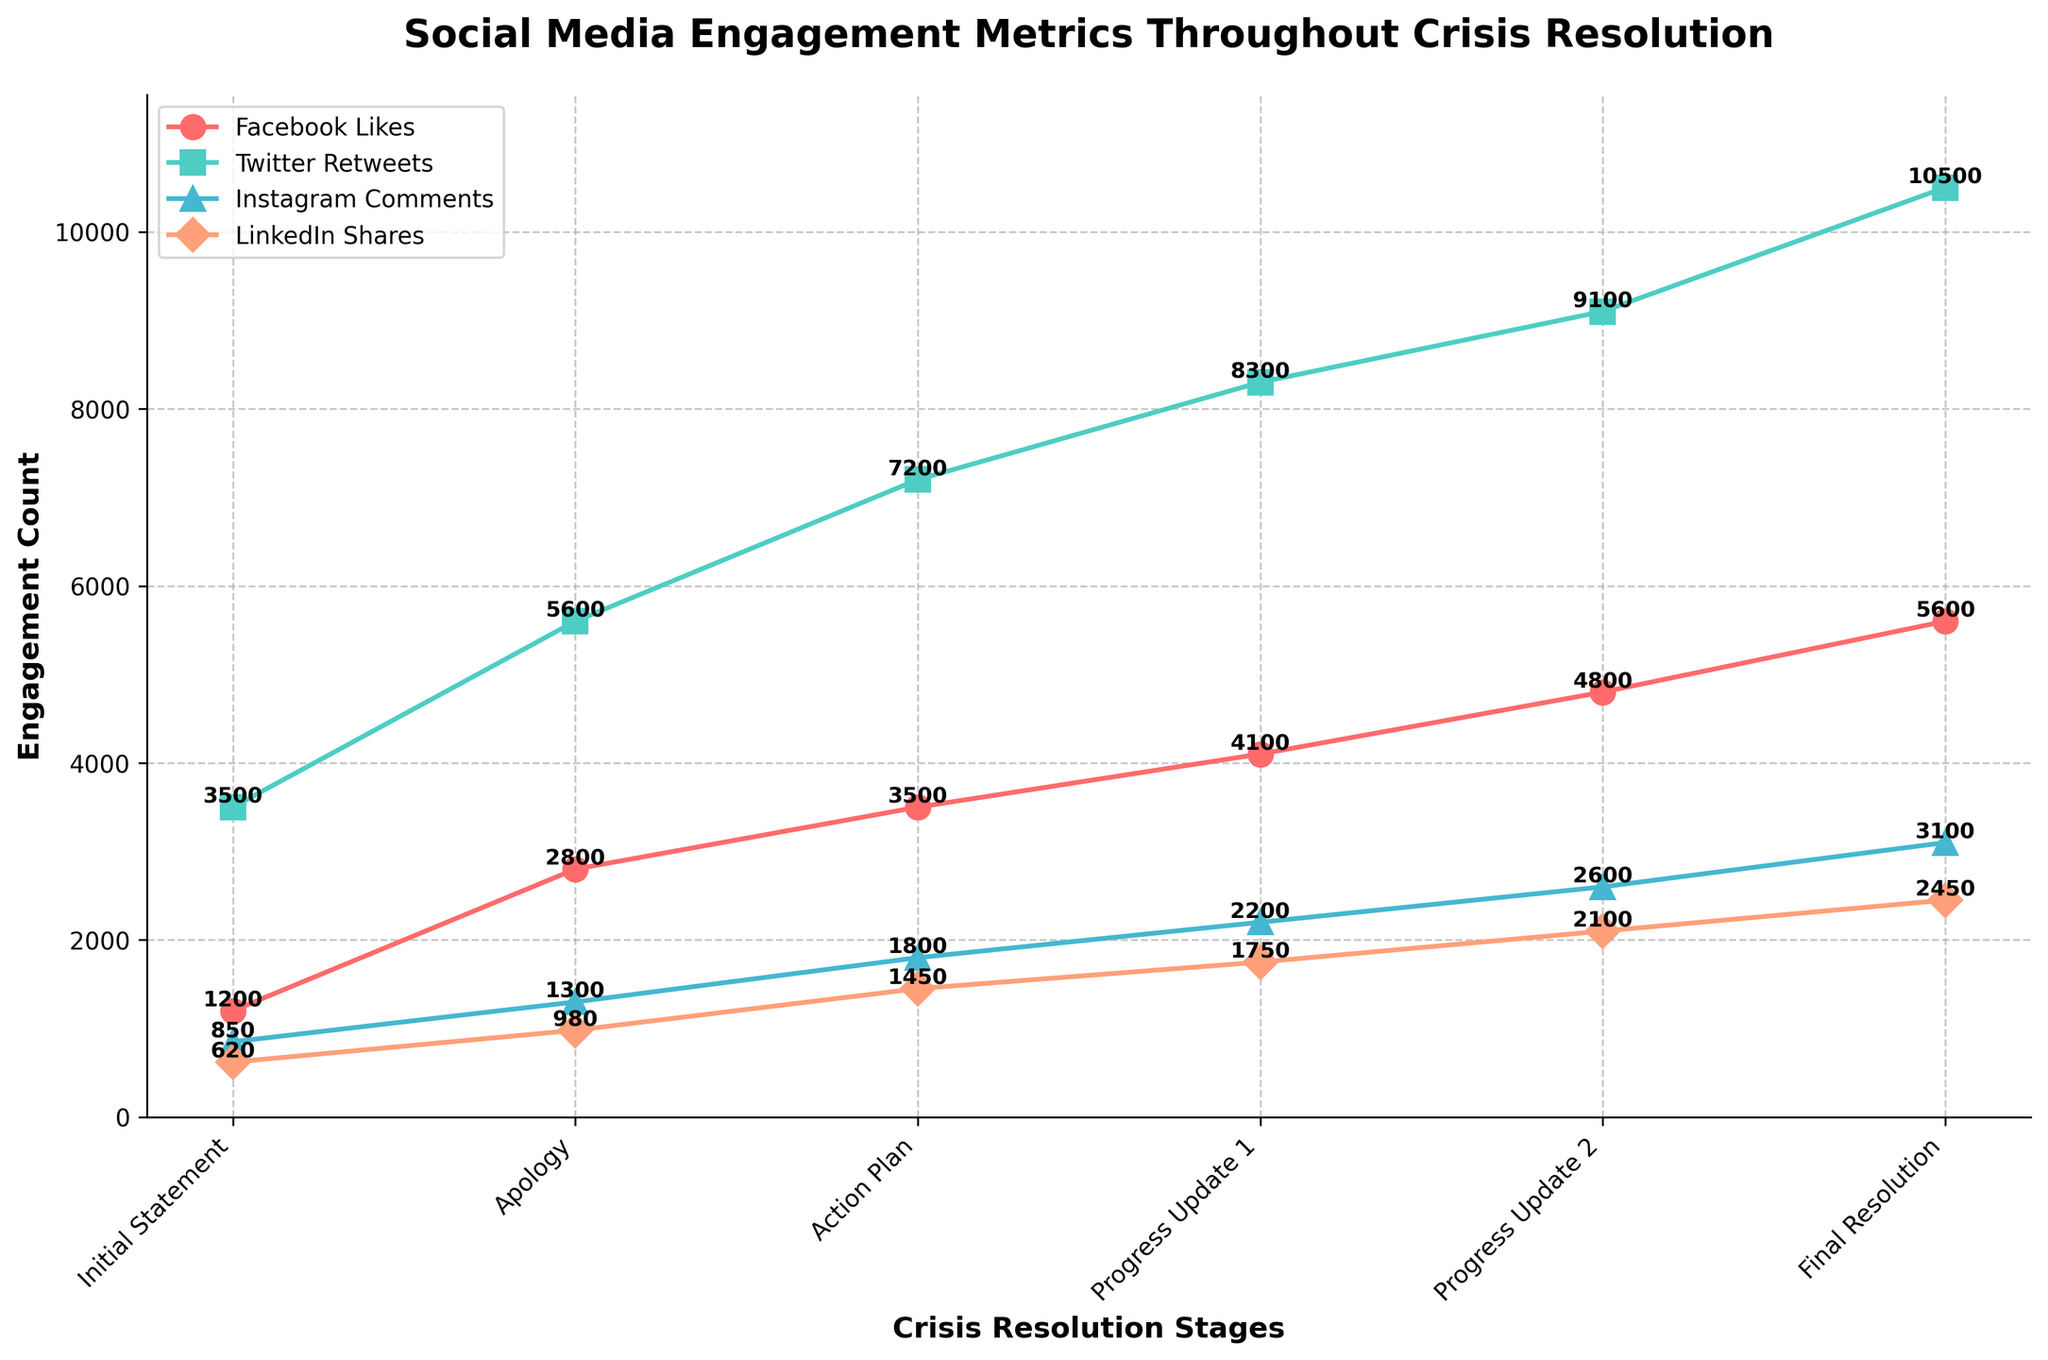What is the title of the plot? The title is usually shown at the top of the graph, and it is the first visual element that catches the viewer's attention to understand the context of the data.
Answer: Social Media Engagement Metrics Throughout Crisis Resolution How many stages are displayed in the plot? By counting the distinct points or labels on the x-axis, we can determine the number of stages shown.
Answer: 6 Which social media platform showed the highest engagement at the Final Resolution stage? By looking at the value at the Final Resolution stage across the different colored lines representing each platform, we can identify the highest engagement.
Answer: Twitter What is the increase in Facebook Likes from the Initial Statement to the Final Resolution? Subtract the value of Facebook Likes at the Initial Statement stage from the value at the Final Resolution stage.
Answer: 4400 At which stage did Instagram Comments exceed 2000? Look at the progression of Instagram Comments across the stages and identify the first instance where the value exceeds 2000.
Answer: Progress Update 1 Compare the Twitter Retweets and LinkedIn Shares at the Apology stage; which is higher and by how much? Identify the values for the Apology stage for both metrics and find the difference by subtracting the LinkedIn Shares from the Twitter Retweets.
Answer: Twitter Retweets by 4620 What is the average number of LinkedIn Shares across all stages? Sum the LinkedIn Shares across all stages and divide by the number of stages.
Answer: 1538.33 How does the engagement on Facebook change over the crisis resolution stages? Track the values of Facebook Likes across each stage and describe the trend of increasing or decreasing engagement.
Answer: Increasing Compare the engagement between the Apology and Progress Update 2 stages for Instagram Comments. Which stage has higher engagement, and what is the increase? Identify the values for both stages for Instagram Comments and find the difference by subtracting the smaller value from the larger one.
Answer: Progress Update 2 by 1300 Which stage saw the highest engagement across all social media platforms combined? Add the values of all engagement metrics for each stage and identify which stage has the highest combined total.
Answer: Final Resolution 